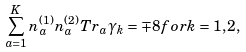<formula> <loc_0><loc_0><loc_500><loc_500>\sum _ { a = 1 } ^ { K } n _ { a } ^ { ( 1 ) } n _ { a } ^ { ( 2 ) } T r _ { a } \gamma _ { k } = \mp 8 f o r k = 1 , 2 ,</formula> 